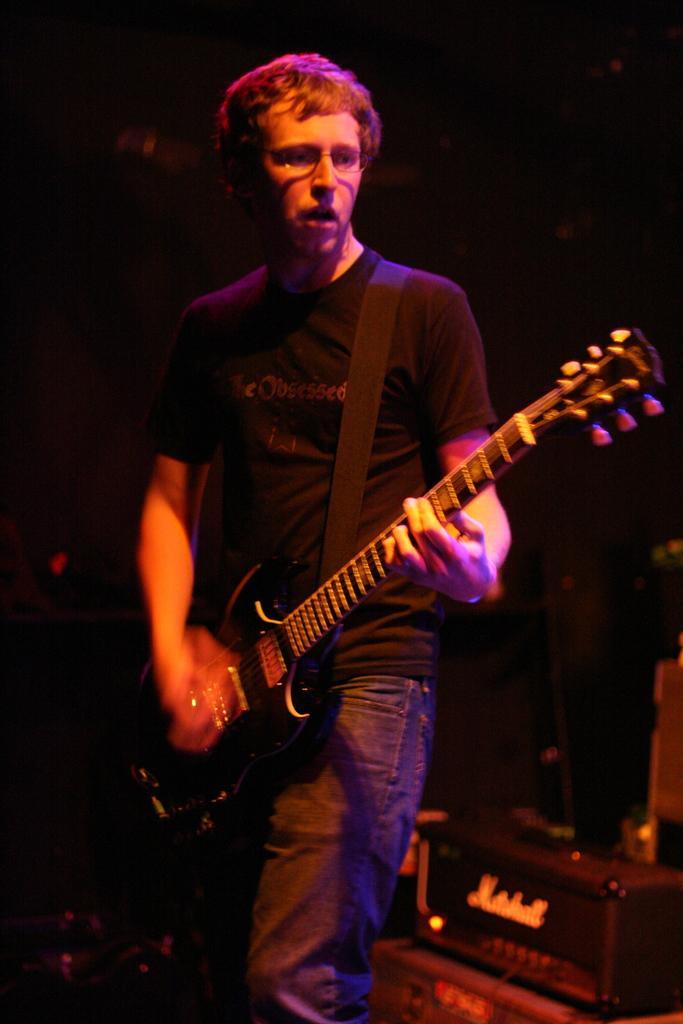Can you describe this image briefly? In the image we can see there is a man who is standing and holding guitar in his hand. 